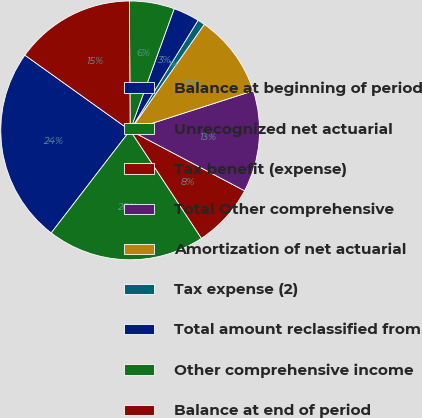<chart> <loc_0><loc_0><loc_500><loc_500><pie_chart><fcel>Balance at beginning of period<fcel>Unrecognized net actuarial<fcel>Tax benefit (expense)<fcel>Total Other comprehensive<fcel>Amortization of net actuarial<fcel>Tax expense (2)<fcel>Total amount reclassified from<fcel>Other comprehensive income<fcel>Balance at end of period<nl><fcel>24.44%<fcel>19.73%<fcel>7.98%<fcel>12.68%<fcel>10.33%<fcel>0.92%<fcel>3.27%<fcel>5.62%<fcel>15.03%<nl></chart> 